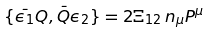Convert formula to latex. <formula><loc_0><loc_0><loc_500><loc_500>\{ \bar { \epsilon _ { 1 } } Q , \bar { Q } \epsilon _ { 2 } \} = 2 \Xi _ { 1 2 } \, n _ { \mu } P ^ { \mu }</formula> 